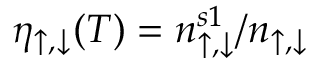<formula> <loc_0><loc_0><loc_500><loc_500>\eta _ { \uparrow , \downarrow } ( T ) = n _ { \uparrow , \downarrow } ^ { s 1 } / n _ { \uparrow , \downarrow }</formula> 